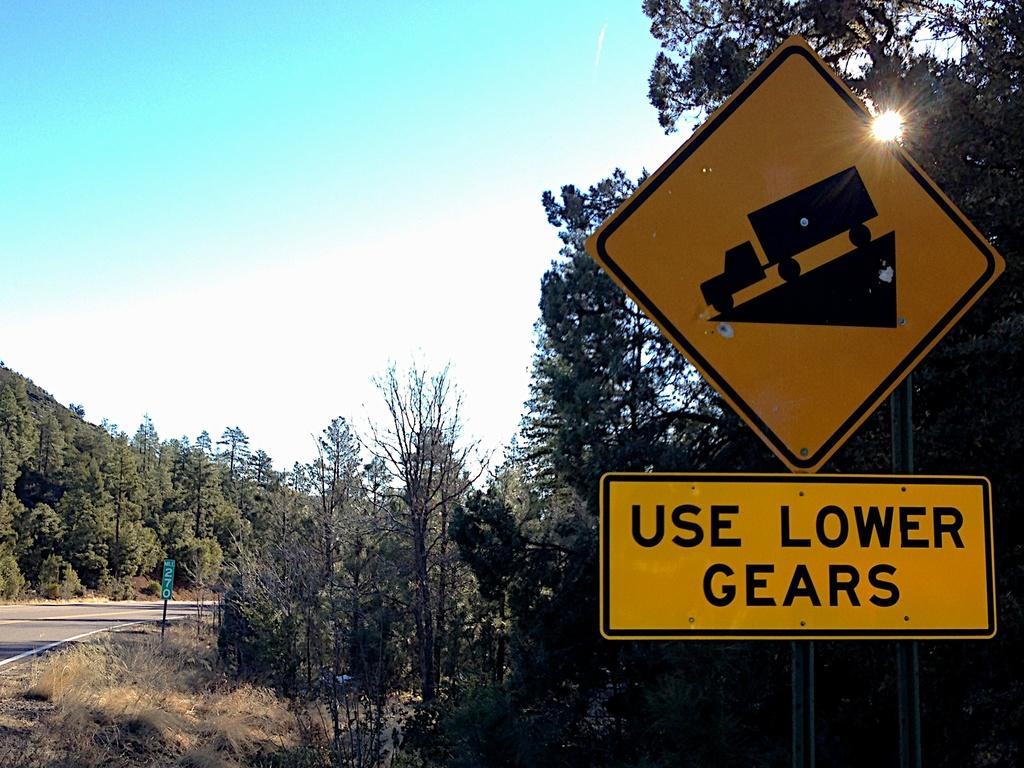<image>
Provide a brief description of the given image. A road sign warning truck drivers to use lower gears when going down the incline. 